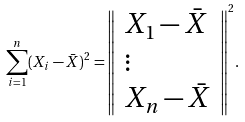<formula> <loc_0><loc_0><loc_500><loc_500>\sum _ { i = 1 } ^ { n } ( X _ { i } - { \bar { X } } ) ^ { 2 } = { \left \| \begin{array} { l } { X _ { 1 } - { \bar { X } } } \\ { \vdots } \\ { X _ { n } - { \bar { X } } } \end{array} \right \| } ^ { 2 } .</formula> 